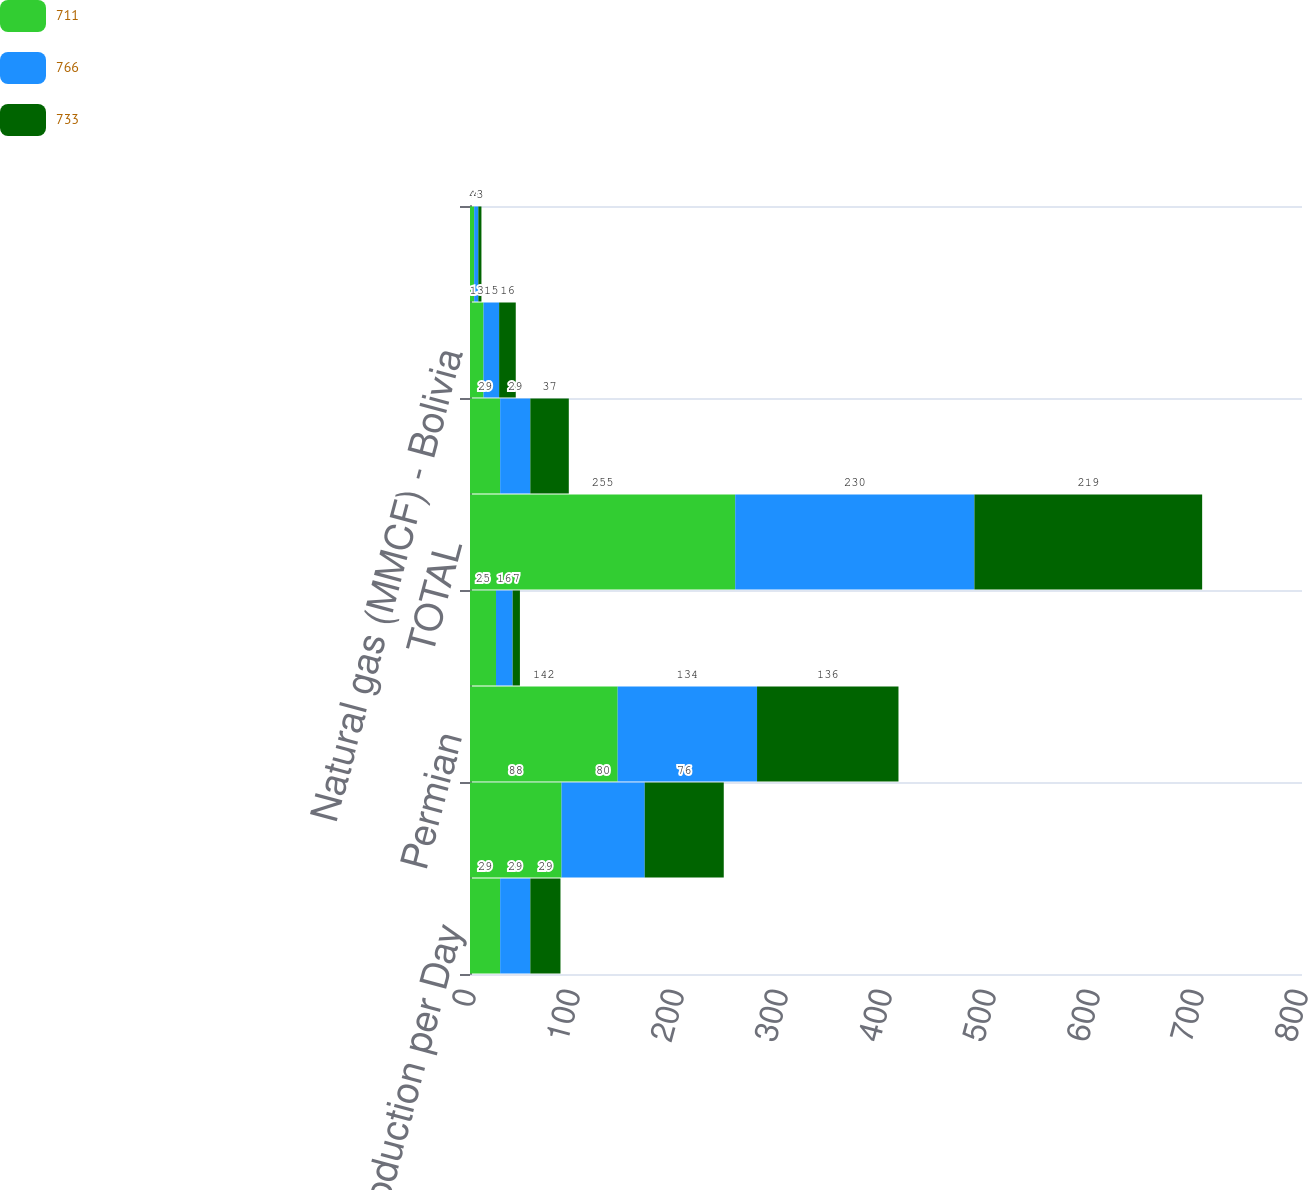Convert chart to OTSL. <chart><loc_0><loc_0><loc_500><loc_500><stacked_bar_chart><ecel><fcel>Production per Day<fcel>California<fcel>Permian<fcel>Midcontinent and Other<fcel>TOTAL<fcel>Oil (MBBL) - Colombia (b)<fcel>Natural gas (MMCF) - Bolivia<fcel>Bahrain<nl><fcel>711<fcel>29<fcel>88<fcel>142<fcel>25<fcel>255<fcel>29<fcel>13<fcel>4<nl><fcel>766<fcel>29<fcel>80<fcel>134<fcel>16<fcel>230<fcel>29<fcel>15<fcel>4<nl><fcel>733<fcel>29<fcel>76<fcel>136<fcel>7<fcel>219<fcel>37<fcel>16<fcel>3<nl></chart> 